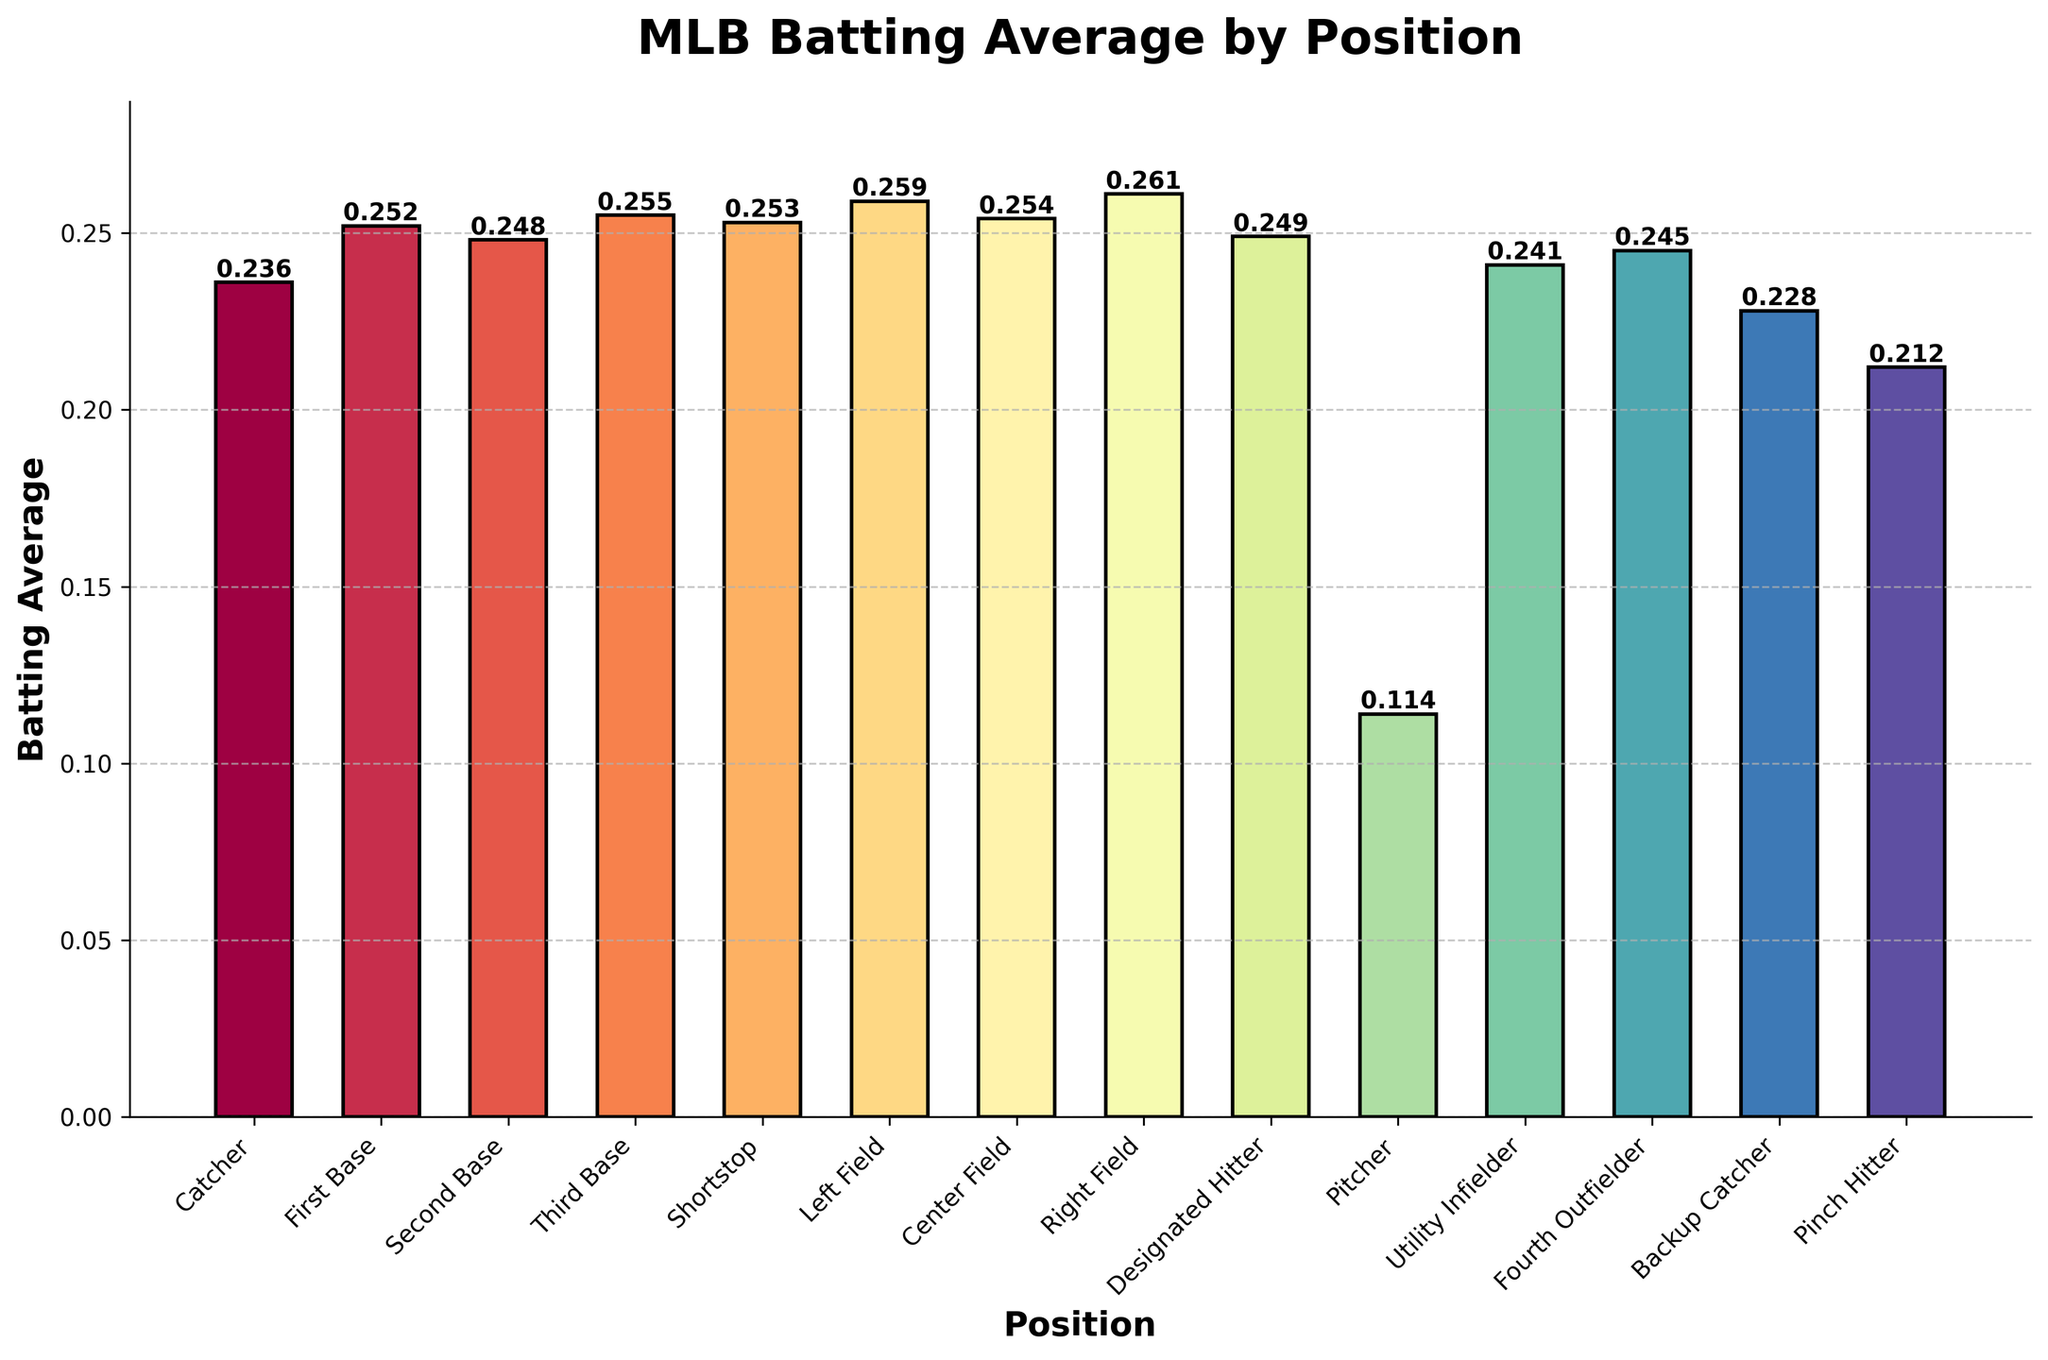Which position has the highest batting average? By examining the heights of the bars, the 'Right Field' position has the tallest bar, indicating the highest batting average.
Answer: Right Field What is the difference in batting average between the best and worst positions? The highest batting average is 0.261 (Right Field) and the lowest is 0.114 (Pitcher). The difference is calculated as 0.261 - 0.114.
Answer: 0.147 Which positions have a batting average greater than 0.250? Looking at the bars' heights, the positions with a batting average greater than 0.250 are First Base (0.252), Third Base (0.255), Shortstop (0.253), Left Field (0.259), Center Field (0.254), and Right Field (0.261).
Answer: First Base, Third Base, Shortstop, Left Field, Center Field, Right Field What is the average batting average of the infield positions (Catcher, First Base, Second Base, Third Base, Shortstop)? Summing the batting averages of the infield positions (0.236 (Catcher) + 0.252 (First Base) + 0.248 (Second Base) + 0.255 (Third Base) + 0.253 (Shortstop)) and then dividing by the number of positions (5). The calculation is (0.236 + 0.252 + 0.248 + 0.255 + 0.253) / 5.
Answer: 0.2488 Is the batting average of Pinch Hitters lower than Backup Catchers? By comparing the bars: Pinch Hitter (0.212) and Backup Catcher (0.228), we observe that the bar for Pinch Hitter is shorter.
Answer: Yes What is the batting average range for the outfield positions (Left Field, Center Field, Right Field, Fourth Outfielder)? Selecting the minimum and maximum values among the outfield positions: the Fourth Outfielder has the lowest at 0.245 and Right Field has the highest at 0.261. The range is calculated as 0.261 - 0.245.
Answer: 0.016 Which position has a higher batting average, Utility Infielder or Second Base? Comparing the heights of the bars for Utility Infielder (0.241) and Second Base (0.248), the Second Base has a higher average.
Answer: Second Base How many positions have a batting average below 0.250? Count the number of bars with heights less than 0.250: there are Catcher (0.236), Second Base (0.248), Designated Hitter (0.249), Utility Infielder (0.241), Fourth Outfielder (0.245), Backup Catcher (0.228), Pinch Hitter (0.212), and Pitcher (0.114). There are 8 positions.
Answer: 8 What's the combined batting average of Utility Infielder and Backup Catcher? Summing the batting averages of Utility Infielder (0.241) and Backup Catcher (0.228), the calculation is 0.241 + 0.228.
Answer: 0.469 